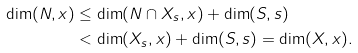<formula> <loc_0><loc_0><loc_500><loc_500>\dim ( N , x ) & \leq \dim ( N \cap X _ { s } , x ) + \dim ( S , s ) \\ & < \dim ( X _ { s } , x ) + \dim ( S , s ) = \dim ( X , x ) .</formula> 